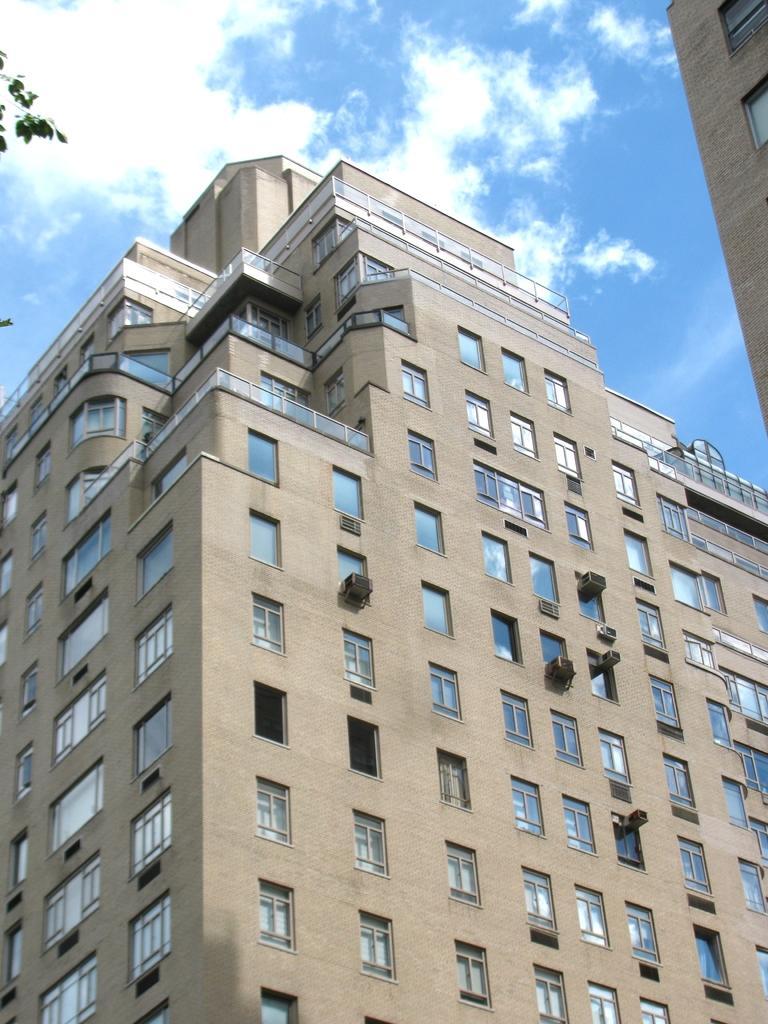Please provide a concise description of this image. In the picture I can see the buildings and glass windows. I can see the air conditioners on the wall of the building. I can see the green leaves on the top left side of the picture. There is another building on the top right side. There are clouds in the sky. 